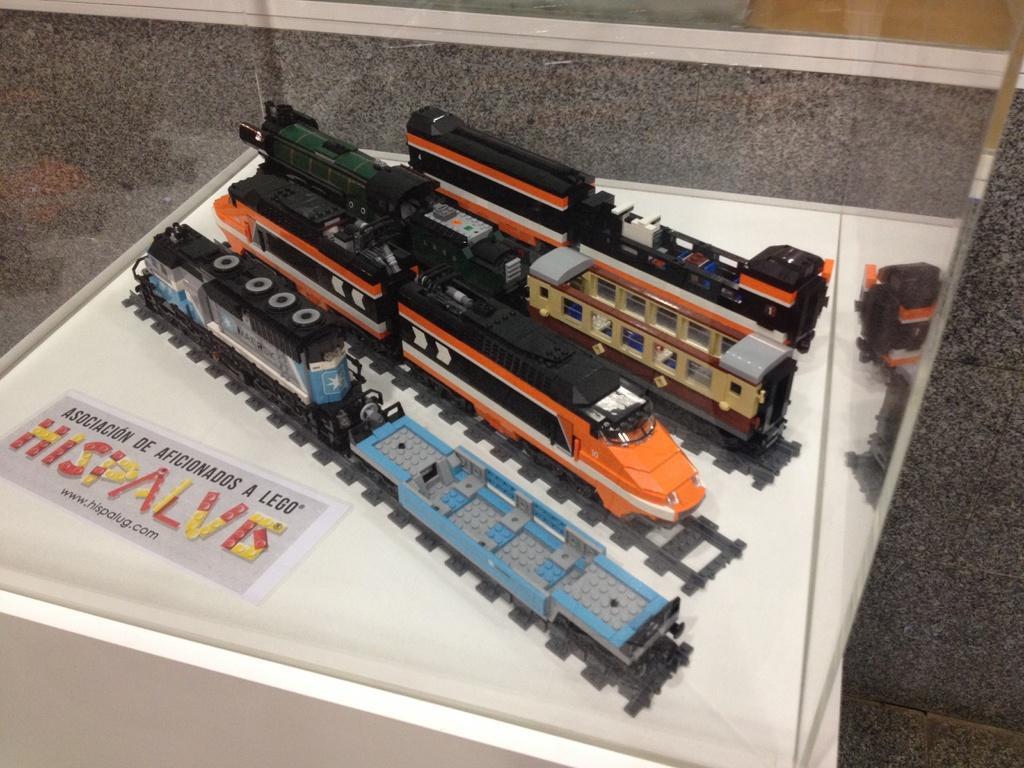How would you summarize this image in a sentence or two? In this image we can see some toy trains in the box, and also there is a poster with some text. 